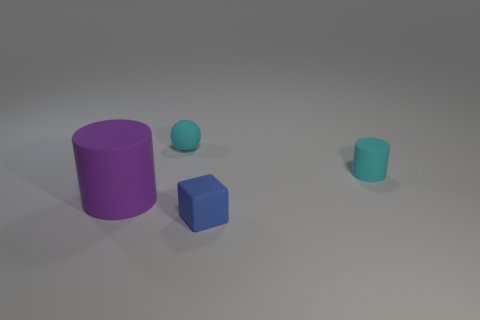Add 3 small rubber blocks. How many objects exist? 7 Subtract all gray spheres. Subtract all blue cylinders. How many spheres are left? 1 Subtract all cubes. How many objects are left? 3 Add 3 purple things. How many purple things are left? 4 Add 3 tiny purple metallic cylinders. How many tiny purple metallic cylinders exist? 3 Subtract 0 red balls. How many objects are left? 4 Subtract all small blue matte objects. Subtract all tiny red matte cylinders. How many objects are left? 3 